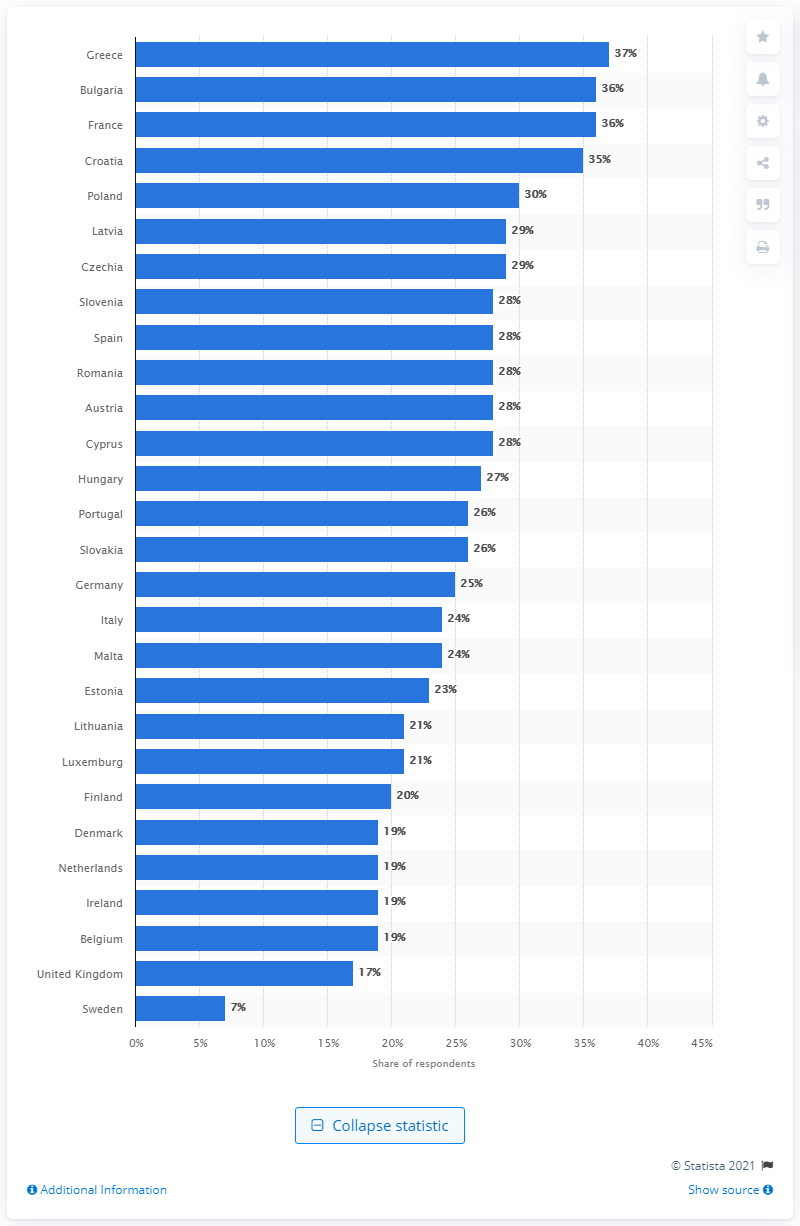Outline some significant characteristics in this image. In 2017, the percentage of smokers in Greece was 37%. 